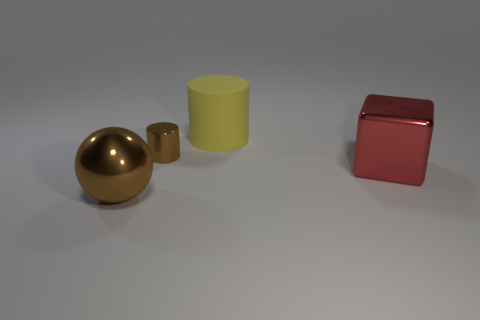Add 2 big rubber things. How many objects exist? 6 Subtract 1 balls. How many balls are left? 0 Subtract all blocks. How many objects are left? 3 Subtract 0 yellow balls. How many objects are left? 4 Subtract all purple cubes. Subtract all cyan spheres. How many cubes are left? 1 Subtract all big brown cubes. Subtract all big brown shiny balls. How many objects are left? 3 Add 1 large yellow things. How many large yellow things are left? 2 Add 1 brown metal objects. How many brown metal objects exist? 3 